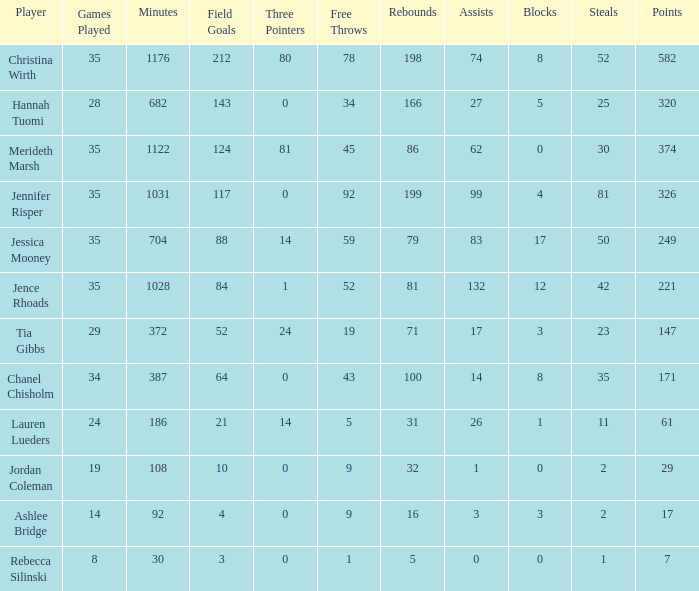In the game with 198 rebounds, how many blockings took place? 8.0. 